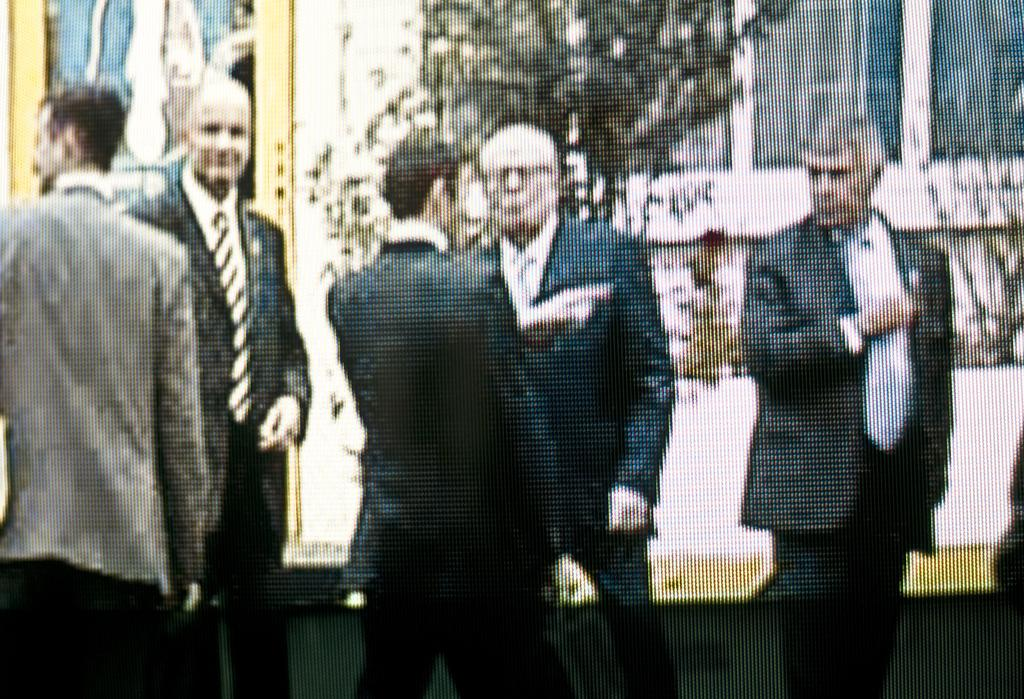What is happening in the image? There is a group of people standing in the image. What can be seen in the background of the image? There are trees and a building in the background of the image. Where is the grandmother sitting in the image? There is no grandmother present in the image. What type of flowers can be seen growing near the trees in the image? There are no flowers mentioned or visible in the image. 